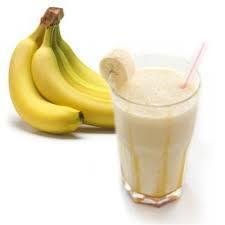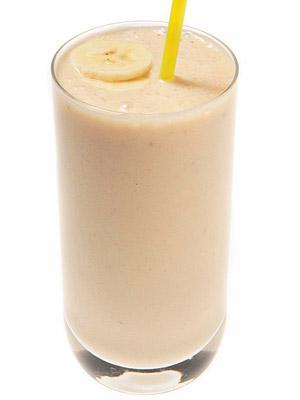The first image is the image on the left, the second image is the image on the right. Evaluate the accuracy of this statement regarding the images: "Each image includes a creamy drink in a glass with a straw in it, and one image includes a slice of banana as garnish on the rim of the glass.". Is it true? Answer yes or no. Yes. The first image is the image on the left, the second image is the image on the right. Analyze the images presented: Is the assertion "The right image contains a smoothie drink next to at least four bananas." valid? Answer yes or no. No. 